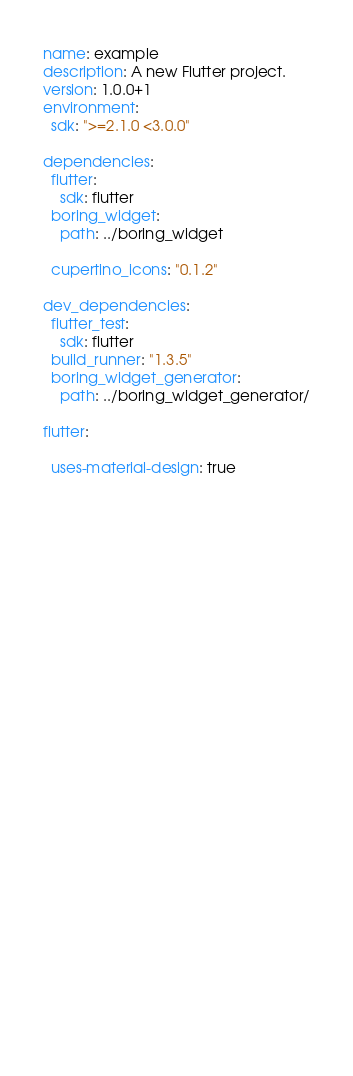Convert code to text. <code><loc_0><loc_0><loc_500><loc_500><_YAML_>name: example
description: A new Flutter project.
version: 1.0.0+1
environment:
  sdk: ">=2.1.0 <3.0.0"

dependencies:
  flutter:
    sdk: flutter
  boring_widget:
    path: ../boring_widget
  
  cupertino_icons: "0.1.2"

dev_dependencies:
  flutter_test:
    sdk: flutter
  build_runner: "1.3.5"
  boring_widget_generator:
    path: ../boring_widget_generator/

flutter:
  
  uses-material-design: true

  
  
  
  

  
  

  
  

  
  
  
  
  
  
  
  
  
  
  
  
  
  
  
  
  
  
  
</code> 